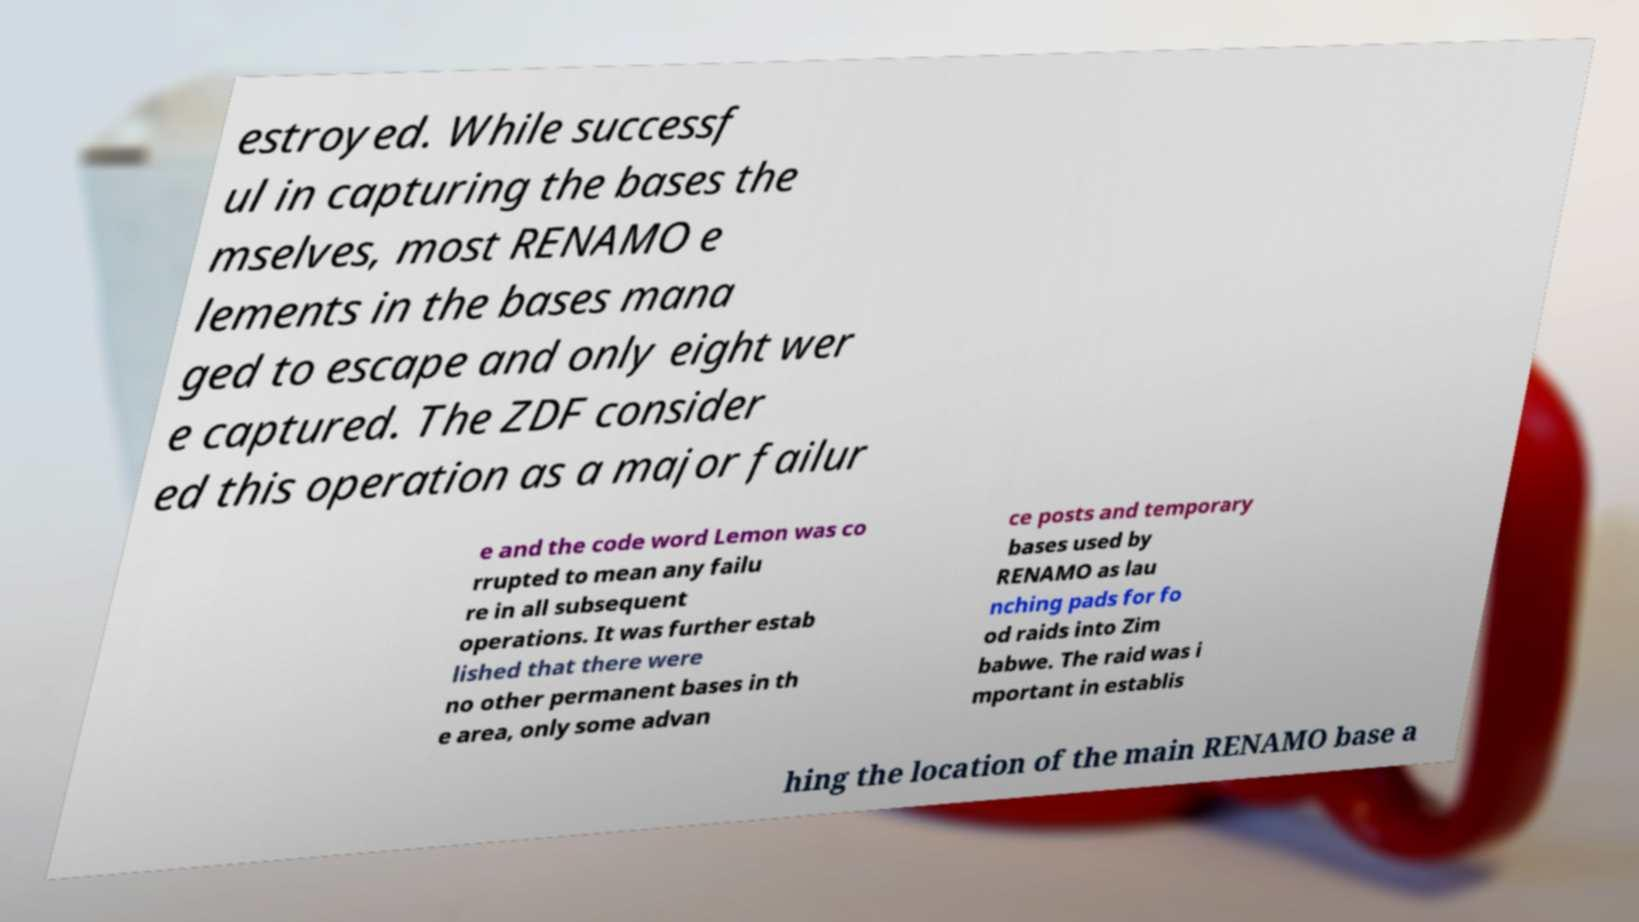Can you accurately transcribe the text from the provided image for me? estroyed. While successf ul in capturing the bases the mselves, most RENAMO e lements in the bases mana ged to escape and only eight wer e captured. The ZDF consider ed this operation as a major failur e and the code word Lemon was co rrupted to mean any failu re in all subsequent operations. It was further estab lished that there were no other permanent bases in th e area, only some advan ce posts and temporary bases used by RENAMO as lau nching pads for fo od raids into Zim babwe. The raid was i mportant in establis hing the location of the main RENAMO base a 